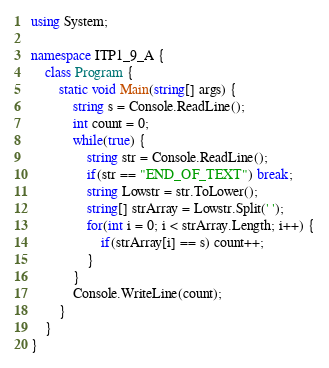Convert code to text. <code><loc_0><loc_0><loc_500><loc_500><_C#_>using System;

namespace ITP1_9_A {
    class Program {
        static void Main(string[] args) {
            string s = Console.ReadLine();
            int count = 0;
            while(true) {
                string str = Console.ReadLine();
                if(str == "END_OF_TEXT") break;
                string Lowstr = str.ToLower();
                string[] strArray = Lowstr.Split(' ');
                for(int i = 0; i < strArray.Length; i++) {
                    if(strArray[i] == s) count++;
                }
            }
            Console.WriteLine(count);
        }
    }
}</code> 